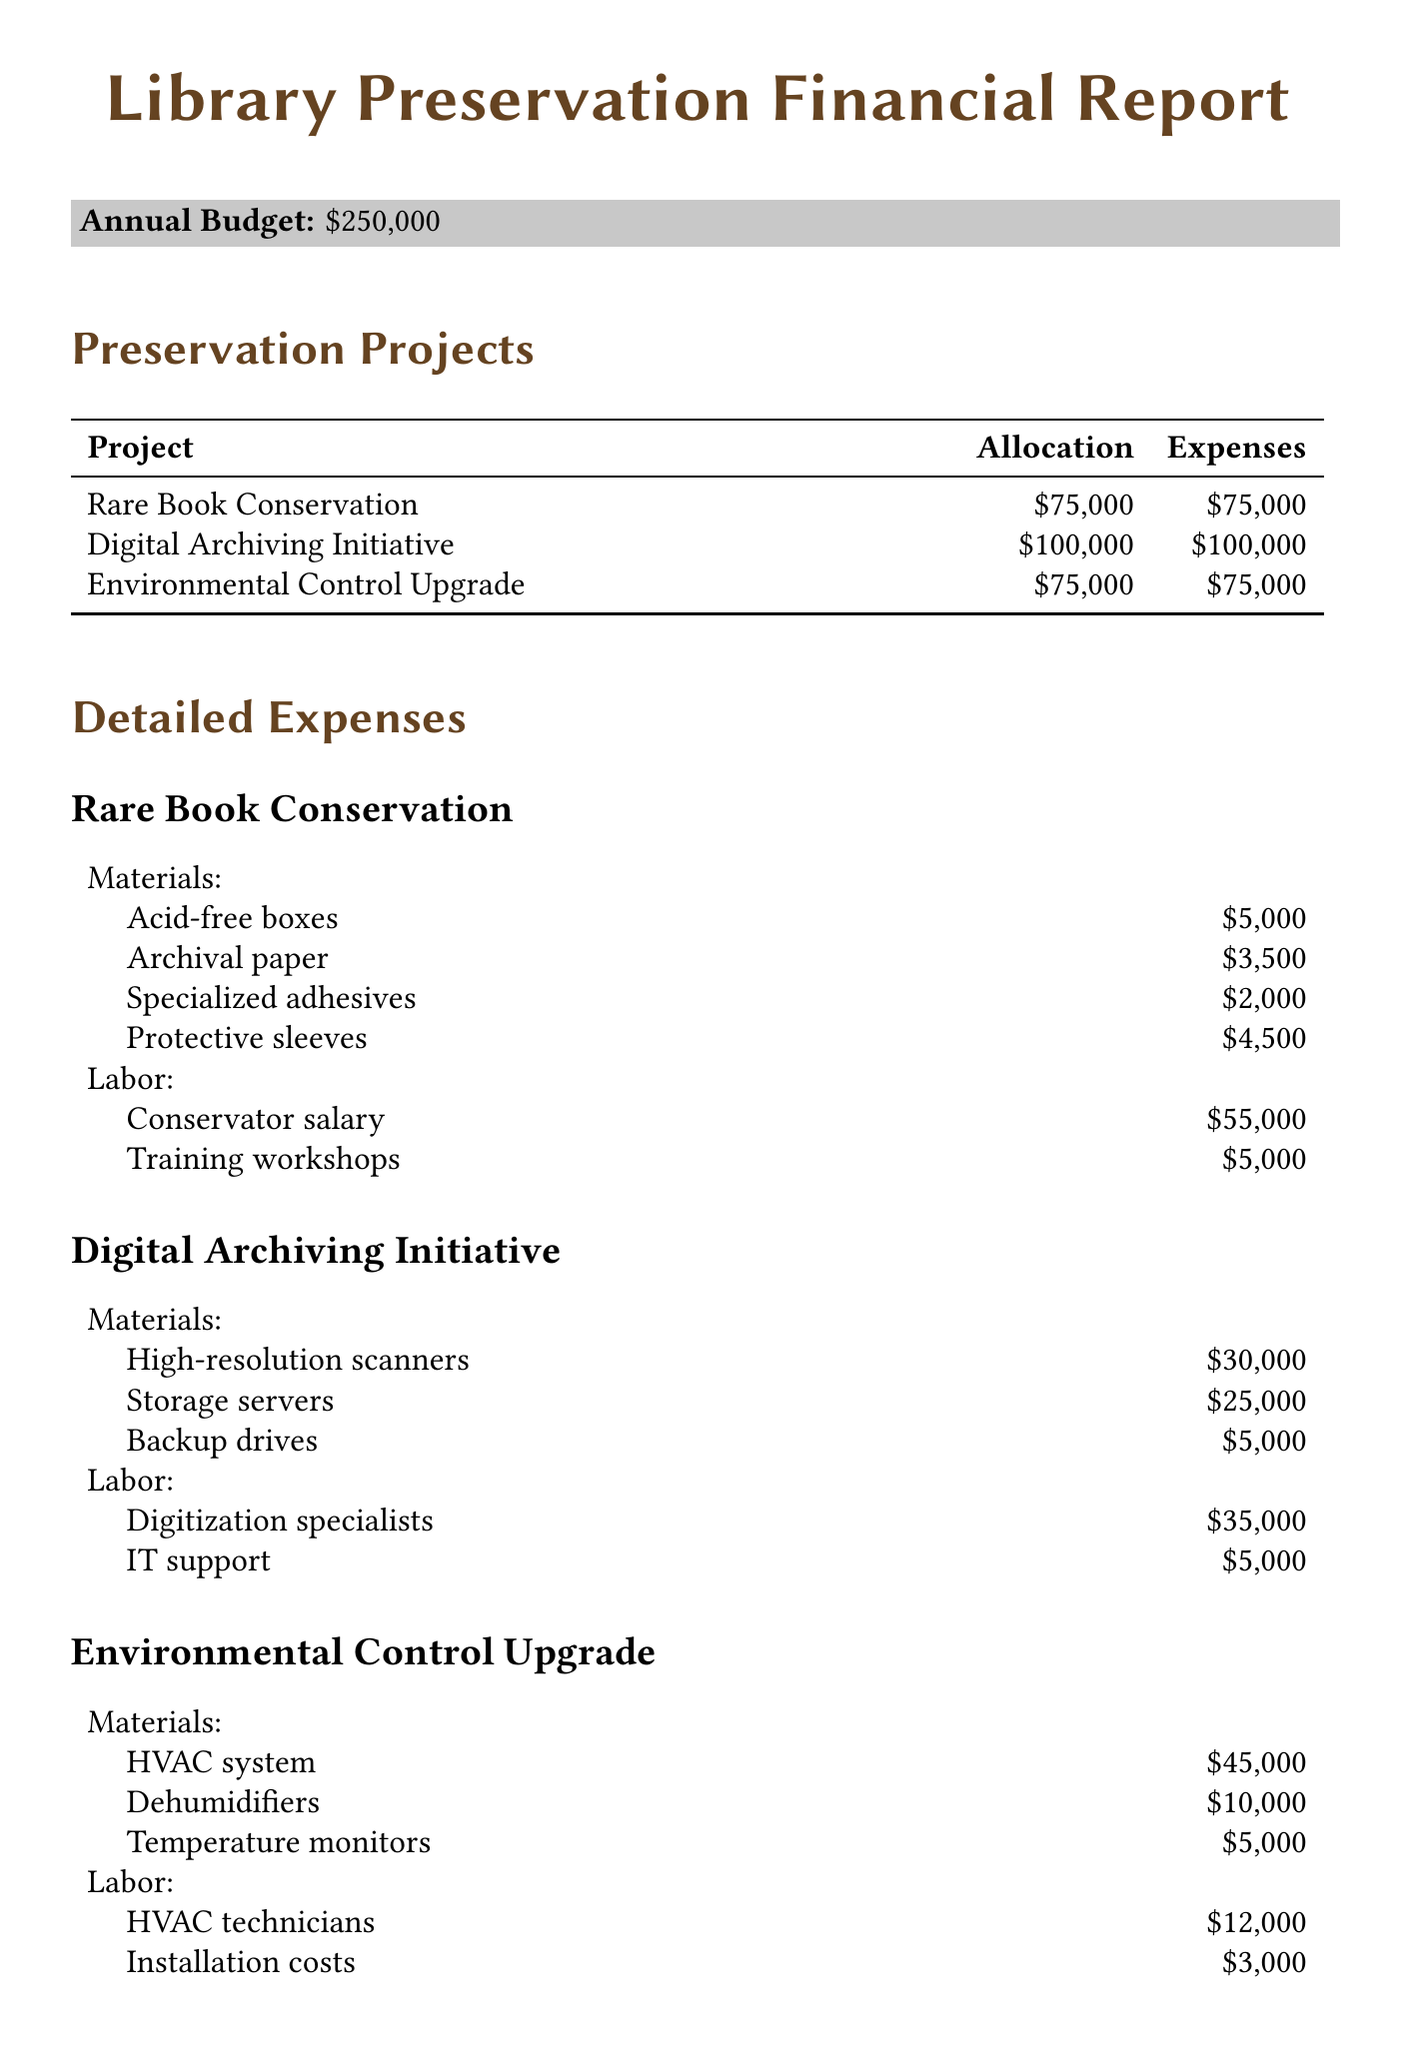What is the annual budget for library preservation projects? The annual budget is stated in the document as $250,000.
Answer: $250,000 How much is allocated for the Digital Archiving Initiative? The allocation for the Digital Archiving Initiative can be found in the budget breakdown, which states $100,000.
Answer: $100,000 What is the total amount for materials in the Rare Book Conservation project? The total amount for materials is the sum of specific expense items in the project: $5,000 + $3,500 + $2,000 + $4,500 = $15,000.
Answer: $15,000 How much is spent on labor for the Environmental Control Upgrade? The labor expenses for the Environmental Control Upgrade include $12,000 + $3,000 = $15,000, as listed in the document.
Answer: $15,000 What is the total funding from the City Council Grant? The amount for the City Council Grant is explicitly mentioned in the funding sources as $150,000.
Answer: $150,000 Which project has the highest allocation? By reviewing the allocation amounts of each project, the Digital Archiving Initiative is noted to have the highest allocation at $100,000.
Answer: Digital Archiving Initiative What is one of the key performance indicators mentioned? The document includes several key performance indicators, one of which is "Number of items preserved."
Answer: Number of items preserved How much is allocated for materials in the Environmental Control Upgrade? The materials allocation for the Environmental Control Upgrade project totals $45,000 + $10,000 + $5,000 = $60,000, as detailed in the document.
Answer: $60,000 What percentage of the total budget is allocated to Rare Book Conservation? The Rare Book Conservation allocation is $75,000 out of a total budget of $250,000, which means it constitutes 30% of the budget.
Answer: 30% 